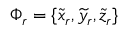Convert formula to latex. <formula><loc_0><loc_0><loc_500><loc_500>\Phi _ { r } = \{ \widetilde { x } _ { r } , \widetilde { y } _ { r } , \widetilde { z } _ { r } \}</formula> 